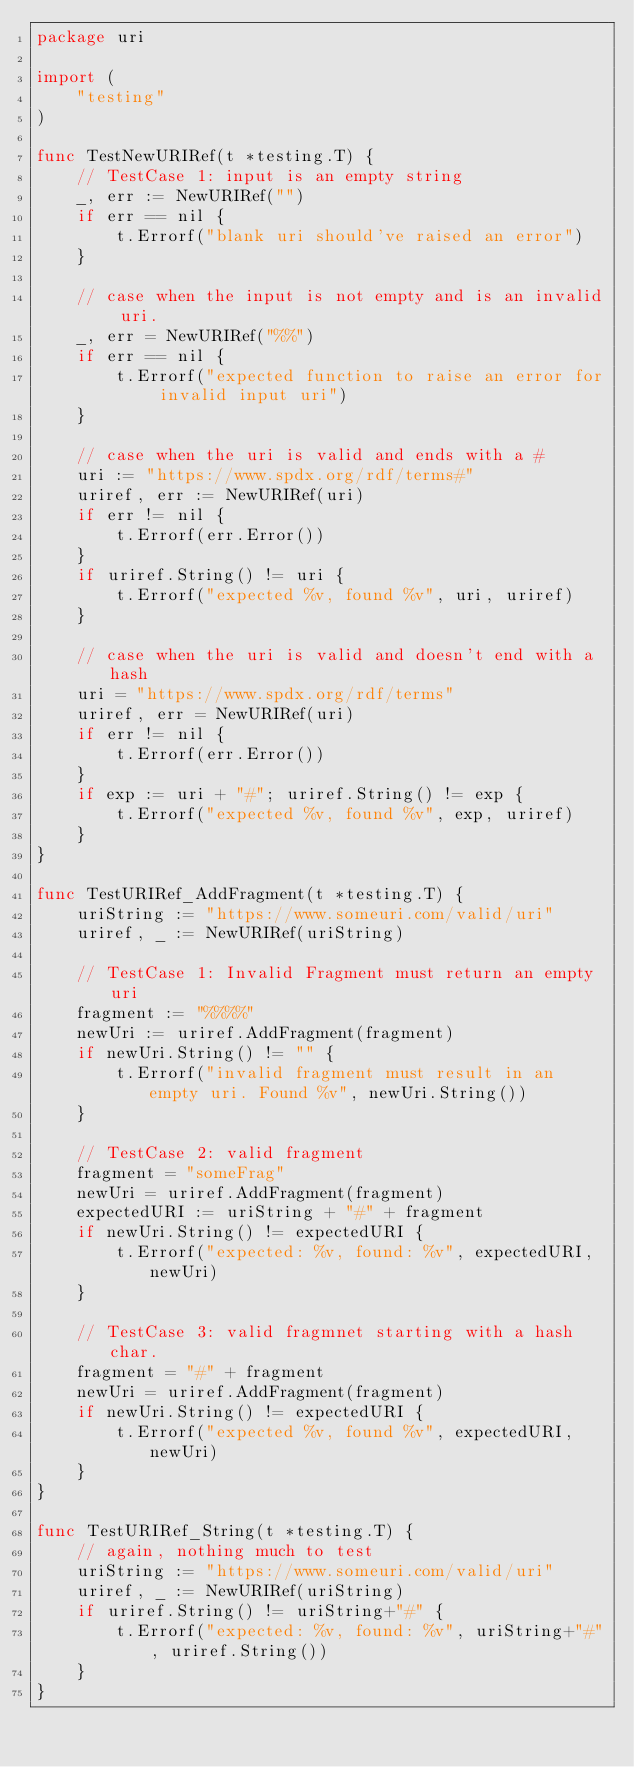Convert code to text. <code><loc_0><loc_0><loc_500><loc_500><_Go_>package uri

import (
	"testing"
)

func TestNewURIRef(t *testing.T) {
	// TestCase 1: input is an empty string
	_, err := NewURIRef("")
	if err == nil {
		t.Errorf("blank uri should've raised an error")
	}

	// case when the input is not empty and is an invalid uri.
	_, err = NewURIRef("%%")
	if err == nil {
		t.Errorf("expected function to raise an error for invalid input uri")
	}

	// case when the uri is valid and ends with a #
	uri := "https://www.spdx.org/rdf/terms#"
	uriref, err := NewURIRef(uri)
	if err != nil {
		t.Errorf(err.Error())
	}
	if uriref.String() != uri {
		t.Errorf("expected %v, found %v", uri, uriref)
	}

	// case when the uri is valid and doesn't end with a hash
	uri = "https://www.spdx.org/rdf/terms"
	uriref, err = NewURIRef(uri)
	if err != nil {
		t.Errorf(err.Error())
	}
	if exp := uri + "#"; uriref.String() != exp {
		t.Errorf("expected %v, found %v", exp, uriref)
	}
}

func TestURIRef_AddFragment(t *testing.T) {
	uriString := "https://www.someuri.com/valid/uri"
	uriref, _ := NewURIRef(uriString)

	// TestCase 1: Invalid Fragment must return an empty uri
	fragment := "%%%%"
	newUri := uriref.AddFragment(fragment)
	if newUri.String() != "" {
		t.Errorf("invalid fragment must result in an empty uri. Found %v", newUri.String())
	}

	// TestCase 2: valid fragment
	fragment = "someFrag"
	newUri = uriref.AddFragment(fragment)
	expectedURI := uriString + "#" + fragment
	if newUri.String() != expectedURI {
		t.Errorf("expected: %v, found: %v", expectedURI, newUri)
	}

	// TestCase 3: valid fragmnet starting with a hash char.
	fragment = "#" + fragment
	newUri = uriref.AddFragment(fragment)
	if newUri.String() != expectedURI {
		t.Errorf("expected %v, found %v", expectedURI, newUri)
	}
}

func TestURIRef_String(t *testing.T) {
	// again, nothing much to test
	uriString := "https://www.someuri.com/valid/uri"
	uriref, _ := NewURIRef(uriString)
	if uriref.String() != uriString+"#" {
		t.Errorf("expected: %v, found: %v", uriString+"#", uriref.String())
	}
}
</code> 